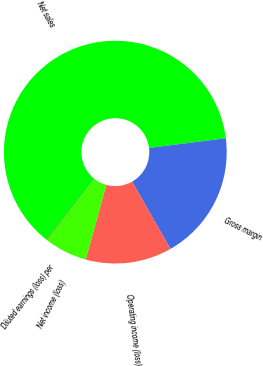<chart> <loc_0><loc_0><loc_500><loc_500><pie_chart><fcel>Net sales<fcel>Gross margin<fcel>Operating income (loss)<fcel>Net income (loss)<fcel>Diluted earnings (loss) per<nl><fcel>62.39%<fcel>18.75%<fcel>12.52%<fcel>6.28%<fcel>0.05%<nl></chart> 